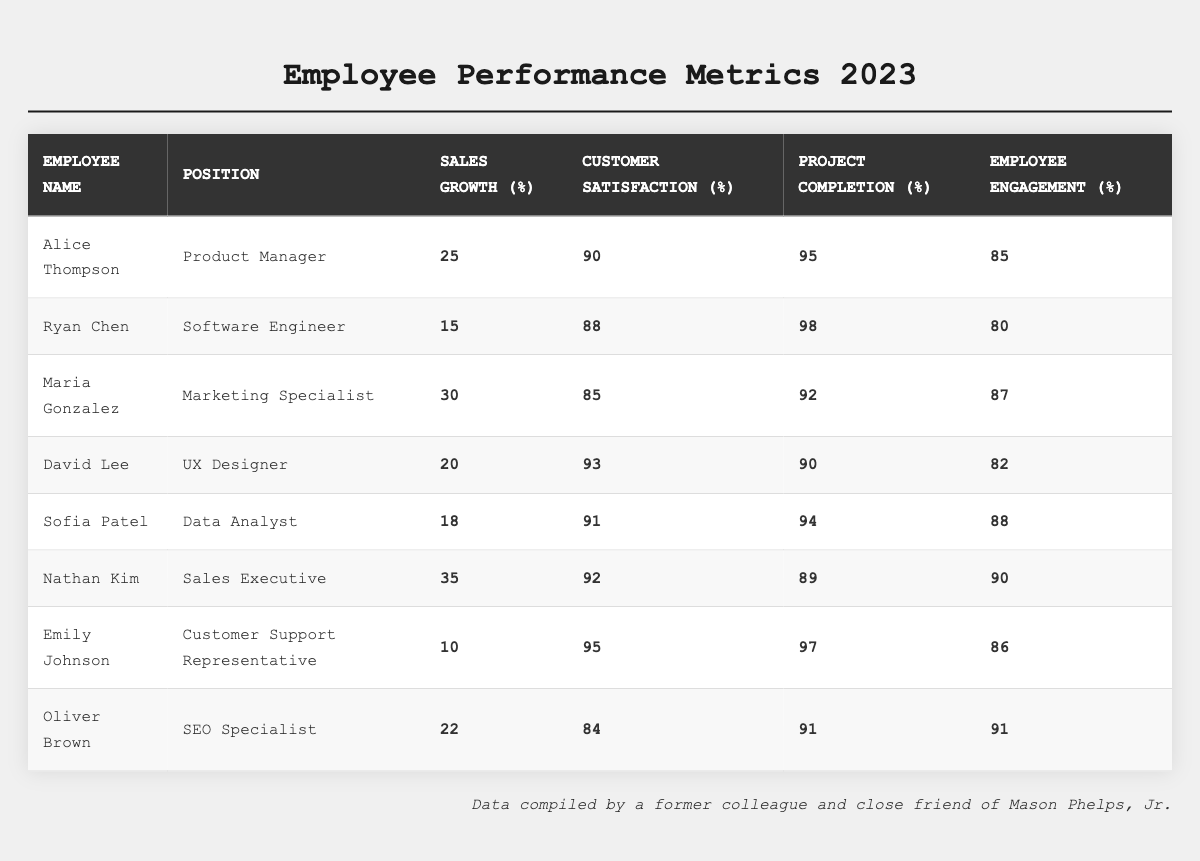What is the name of the employee with the highest sales growth? By reviewing the sales growth percentages in the table, Nathan Kim has the highest sales growth of 35%.
Answer: Nathan Kim Which employee has the highest customer satisfaction score? Looking at the customer satisfaction scores, Emily Johnson has the highest score at 95%.
Answer: Emily Johnson What is the average project completion percentage of all employees? First, sum the project completion percentages: (95 + 98 + 92 + 90 + 94 + 89 + 97 + 91) = 786. Then, divide by the number of employees (8): 786 / 8 = 98.25.
Answer: 98.25 Is Ryan Chen's employee engagement score above 80%? Checking Ryan Chen's employee engagement score, it is 80%, which is not above 80%.
Answer: No How many employees have a customer satisfaction score higher than 90%? The employees with scores higher than 90% are Alice Thompson (90%), David Lee (93%), Sofia Patel (91%), Nathan Kim (92%), and Emily Johnson (95%). That totals to 5 employees.
Answer: 5 What is the difference in employee engagement between the best and worst performing individuals? Alice Thompson has the highest employee engagement at 85%, while Ryan Chen has the lowest at 80%. The difference is 85 - 80 = 5.
Answer: 5 Which position has the highest average sales growth among its employees? For sales growth: Product Manager (25), Software Engineer (15), Marketing Specialist (30), UX Designer (20), Data Analyst (18), Sales Executive (35), Customer Support Representative (10), SEO Specialist (22). Average for Sales Executive: 35, which is the highest.
Answer: Sales Executive Identify the employee with the lowest project completion percentage. Looking through the project completion percentages, Nathan Kim has the lowest at 89%.
Answer: Nathan Kim Which two employees have the closest scores in employee engagement? Comparing employee engagement scores, Sofia Patel (88%) and Nathan Kim (90%) have the closest scores with a difference of 2%.
Answer: Sofia Patel and Nathan Kim What is the median value of customer satisfaction scores? When ordered, the customer satisfaction scores are 84, 85, 88, 90, 91, 92, 93, 95. The median is the average of the two middle scores (90 and 91): (90 + 91) / 2 = 90.5.
Answer: 90.5 